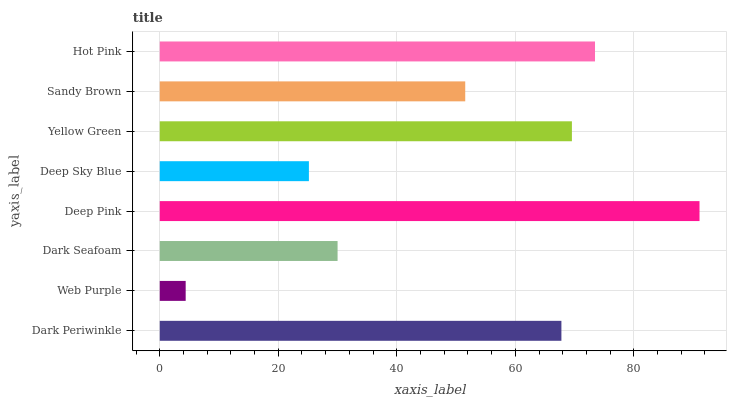Is Web Purple the minimum?
Answer yes or no. Yes. Is Deep Pink the maximum?
Answer yes or no. Yes. Is Dark Seafoam the minimum?
Answer yes or no. No. Is Dark Seafoam the maximum?
Answer yes or no. No. Is Dark Seafoam greater than Web Purple?
Answer yes or no. Yes. Is Web Purple less than Dark Seafoam?
Answer yes or no. Yes. Is Web Purple greater than Dark Seafoam?
Answer yes or no. No. Is Dark Seafoam less than Web Purple?
Answer yes or no. No. Is Dark Periwinkle the high median?
Answer yes or no. Yes. Is Sandy Brown the low median?
Answer yes or no. Yes. Is Deep Sky Blue the high median?
Answer yes or no. No. Is Dark Periwinkle the low median?
Answer yes or no. No. 